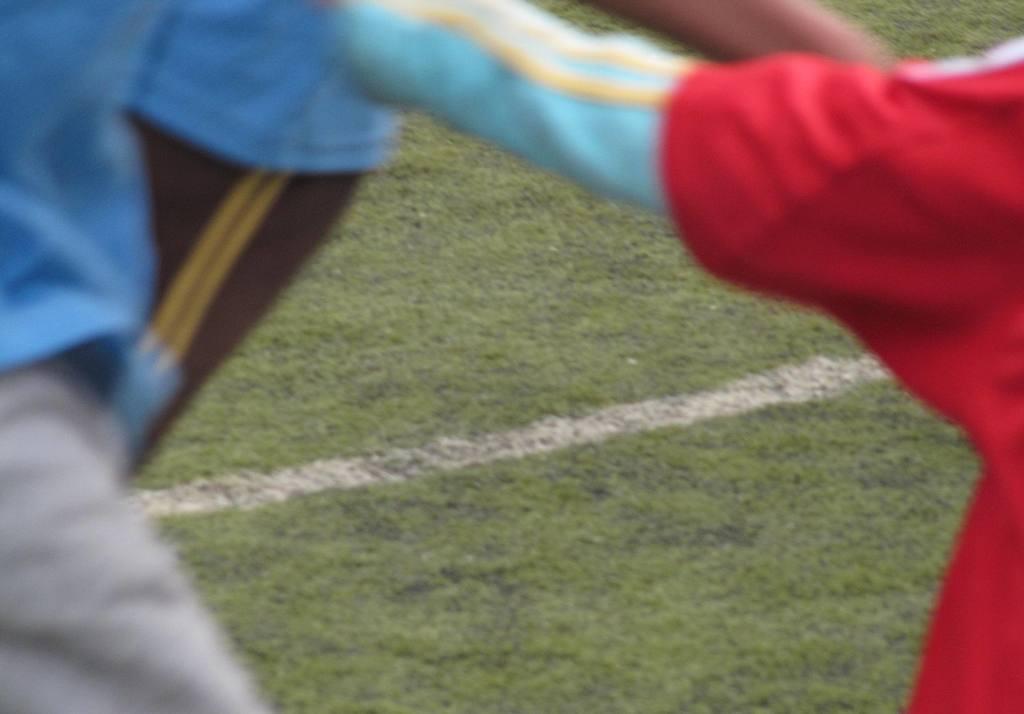Can you describe this image briefly? In this picture It looks like there are humans on either side of this image, in the middle there is the grass. 